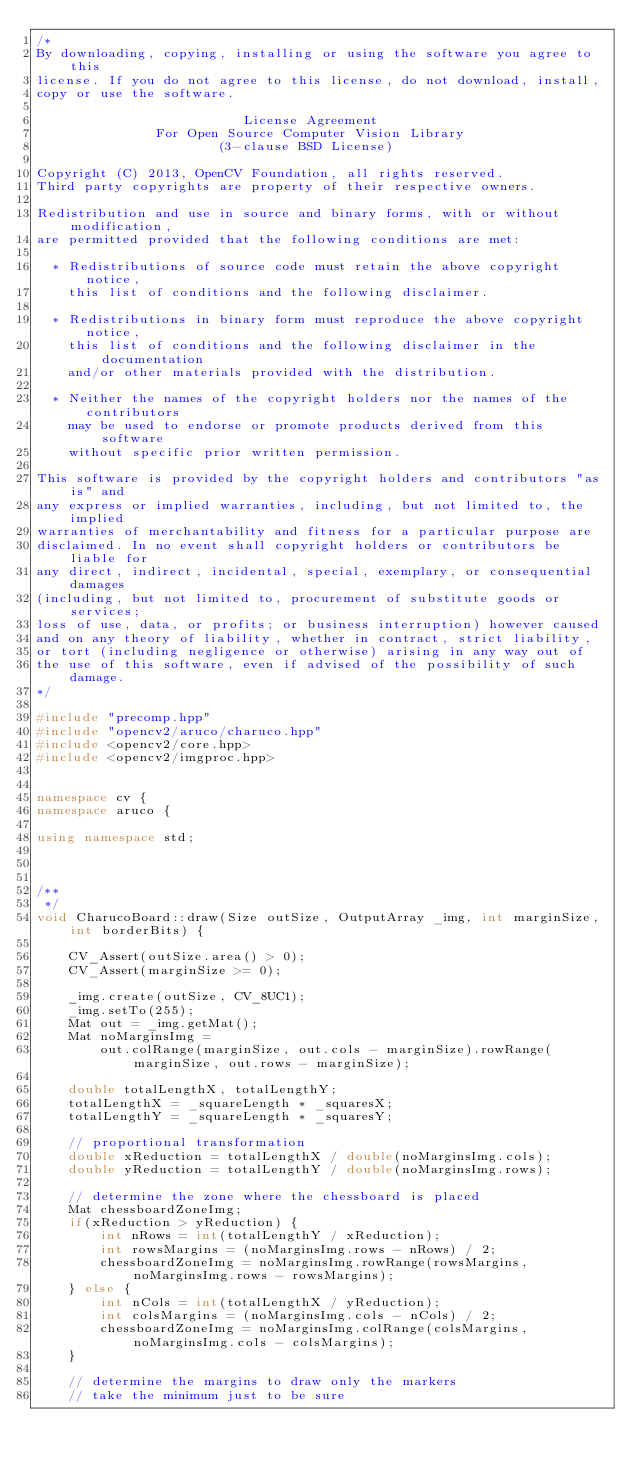<code> <loc_0><loc_0><loc_500><loc_500><_C++_>/*
By downloading, copying, installing or using the software you agree to this
license. If you do not agree to this license, do not download, install,
copy or use the software.

                          License Agreement
               For Open Source Computer Vision Library
                       (3-clause BSD License)

Copyright (C) 2013, OpenCV Foundation, all rights reserved.
Third party copyrights are property of their respective owners.

Redistribution and use in source and binary forms, with or without modification,
are permitted provided that the following conditions are met:

  * Redistributions of source code must retain the above copyright notice,
    this list of conditions and the following disclaimer.

  * Redistributions in binary form must reproduce the above copyright notice,
    this list of conditions and the following disclaimer in the documentation
    and/or other materials provided with the distribution.

  * Neither the names of the copyright holders nor the names of the contributors
    may be used to endorse or promote products derived from this software
    without specific prior written permission.

This software is provided by the copyright holders and contributors "as is" and
any express or implied warranties, including, but not limited to, the implied
warranties of merchantability and fitness for a particular purpose are
disclaimed. In no event shall copyright holders or contributors be liable for
any direct, indirect, incidental, special, exemplary, or consequential damages
(including, but not limited to, procurement of substitute goods or services;
loss of use, data, or profits; or business interruption) however caused
and on any theory of liability, whether in contract, strict liability,
or tort (including negligence or otherwise) arising in any way out of
the use of this software, even if advised of the possibility of such damage.
*/

#include "precomp.hpp"
#include "opencv2/aruco/charuco.hpp"
#include <opencv2/core.hpp>
#include <opencv2/imgproc.hpp>


namespace cv {
namespace aruco {

using namespace std;



/**
 */
void CharucoBoard::draw(Size outSize, OutputArray _img, int marginSize, int borderBits) {

    CV_Assert(outSize.area() > 0);
    CV_Assert(marginSize >= 0);

    _img.create(outSize, CV_8UC1);
    _img.setTo(255);
    Mat out = _img.getMat();
    Mat noMarginsImg =
        out.colRange(marginSize, out.cols - marginSize).rowRange(marginSize, out.rows - marginSize);

    double totalLengthX, totalLengthY;
    totalLengthX = _squareLength * _squaresX;
    totalLengthY = _squareLength * _squaresY;

    // proportional transformation
    double xReduction = totalLengthX / double(noMarginsImg.cols);
    double yReduction = totalLengthY / double(noMarginsImg.rows);

    // determine the zone where the chessboard is placed
    Mat chessboardZoneImg;
    if(xReduction > yReduction) {
        int nRows = int(totalLengthY / xReduction);
        int rowsMargins = (noMarginsImg.rows - nRows) / 2;
        chessboardZoneImg = noMarginsImg.rowRange(rowsMargins, noMarginsImg.rows - rowsMargins);
    } else {
        int nCols = int(totalLengthX / yReduction);
        int colsMargins = (noMarginsImg.cols - nCols) / 2;
        chessboardZoneImg = noMarginsImg.colRange(colsMargins, noMarginsImg.cols - colsMargins);
    }

    // determine the margins to draw only the markers
    // take the minimum just to be sure</code> 